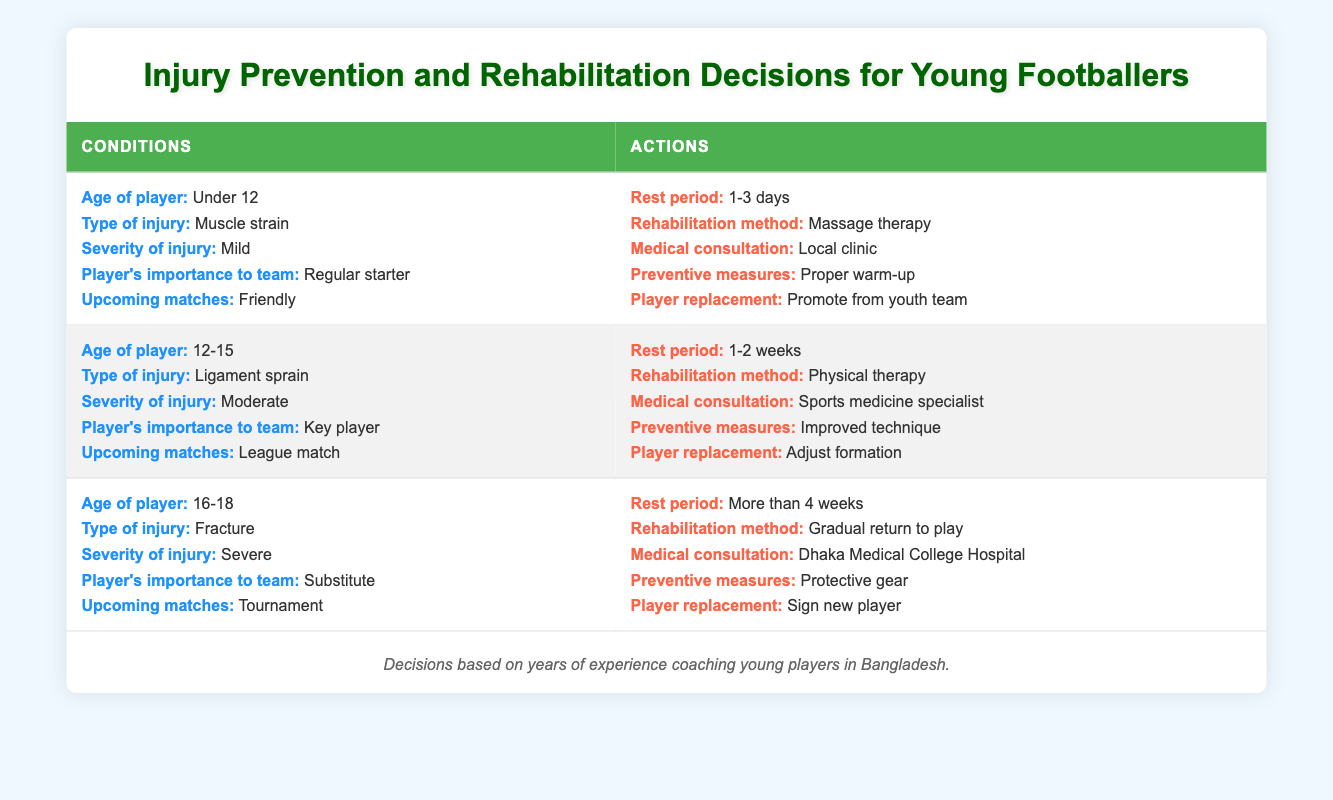What is the recommended rest period for a player aged Under 12 with a mild muscle strain? The table indicates that for an Under 12 player with a mild muscle strain, the recommended rest period is between 1-3 days. This can be found directly in the first row of the conditions and actions.
Answer: 1-3 days Which rehabilitation method should be used for a 12-15-year-old key player with a moderate ligament sprain? According to the second row of the table, for a 12-15-year-old key player with a moderate ligament sprain, the recommended rehabilitation method is physical therapy.
Answer: Physical therapy Is it true that a substitute player with a severe fracture requires a medical consultation at Dhaka Medical College Hospital? Yes, the data in the third row confirms that a substitute player with a severe fracture should consult the Dhaka Medical College Hospital. This is directly stated under the actions section for that injury type.
Answer: Yes What are the preventive measures recommended for a regular starter with a mild muscle strain? The preventive measures for a regular starter with a mild muscle strain are listed as "Proper warm-up" as detailed in the first rule of the table. This informs the preventative actions taken after the injury diagnosis.
Answer: Proper warm-up If a 16-18-year-old has a severe fracture, what is the expected rest period? The third row indicates that a 16-18-year-old player with a severe fracture should have a rest period of more than 4 weeks based on the severity and type of injury outlined for that age group.
Answer: More than 4 weeks What is the relationship between the player's importance and the type of injury regarding player replacement decisions? Analyzing the table indicates that a key player (age 12-15, ligament sprain) leads to adjusting the formation, while a substitute with a severe fracture requires signing a new player. This relationship shows that injuries to players deemed more important influence more immediate and significant changes in team strategy.
Answer: More important players lead to different replacement strategies How many weeks of rehabilitation are suggested for a substitute player injured with a severe fracture? For a substitute player with a severe fracture, the table suggests a rehabilitation method of gradual return to play following a rest period of more than 4 weeks. Therefore, the expectation for rehabilitation follows from the stated conditions.
Answer: More than 4 weeks Which age group is advised to promote from the youth team if a regular starter experiences a mild muscle strain? The table mentions the promotion from the youth team is an action for an Under 12 player experiencing a mild muscle strain, making this approach specified uniquely for that age group.
Answer: Under 12 What is the primary preventive measure recommended for a player aged 12-15 with a moderate ligament sprain? The preventive measure for a 12-15-year-old player who suffers a moderate ligament sprain is improved technique, as outlined in the second set of conditions and actions in the table.
Answer: Improved technique 